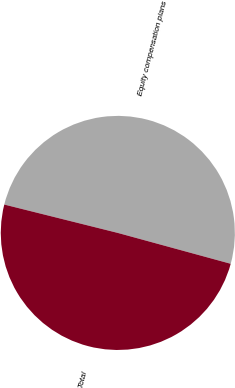Convert chart to OTSL. <chart><loc_0><loc_0><loc_500><loc_500><pie_chart><fcel>Equity compensation plans<fcel>Total<nl><fcel>50.35%<fcel>49.65%<nl></chart> 